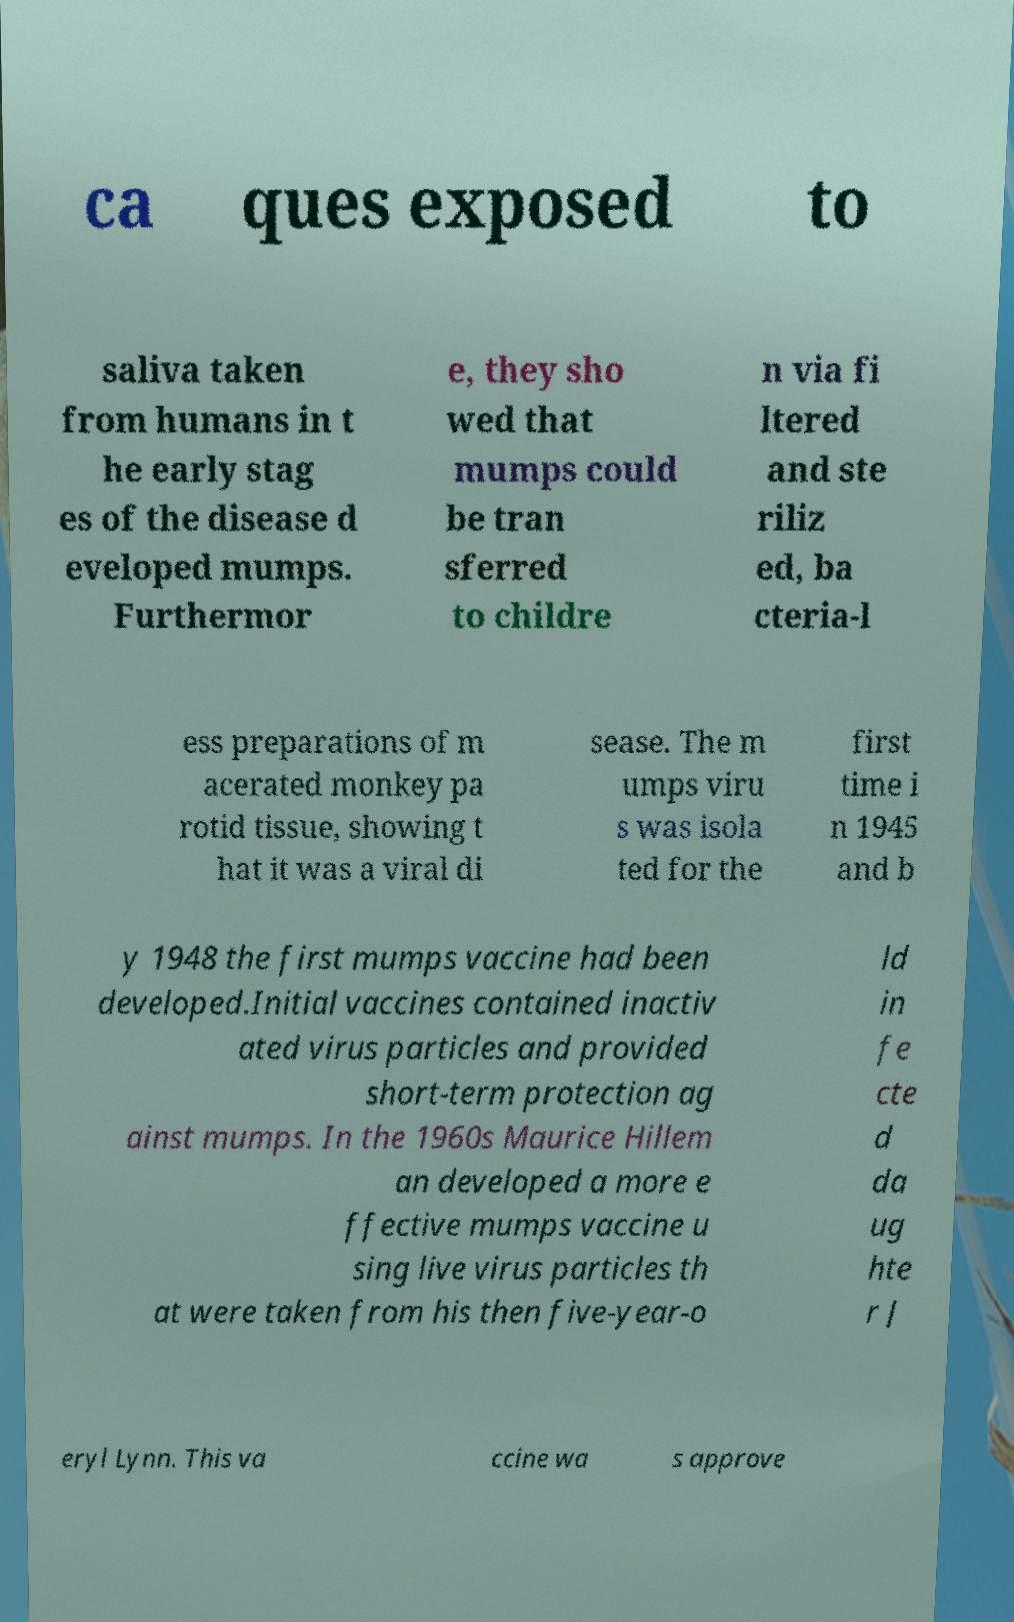Can you accurately transcribe the text from the provided image for me? ca ques exposed to saliva taken from humans in t he early stag es of the disease d eveloped mumps. Furthermor e, they sho wed that mumps could be tran sferred to childre n via fi ltered and ste riliz ed, ba cteria-l ess preparations of m acerated monkey pa rotid tissue, showing t hat it was a viral di sease. The m umps viru s was isola ted for the first time i n 1945 and b y 1948 the first mumps vaccine had been developed.Initial vaccines contained inactiv ated virus particles and provided short-term protection ag ainst mumps. In the 1960s Maurice Hillem an developed a more e ffective mumps vaccine u sing live virus particles th at were taken from his then five-year-o ld in fe cte d da ug hte r J eryl Lynn. This va ccine wa s approve 